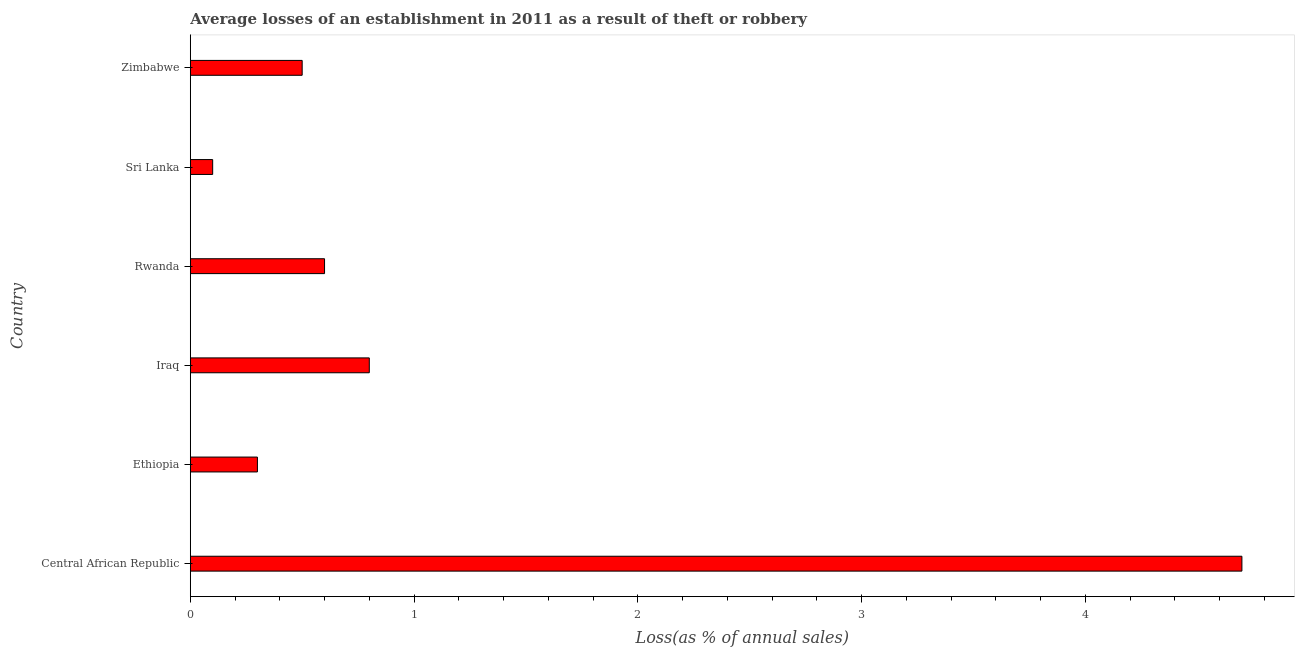Does the graph contain grids?
Offer a terse response. No. What is the title of the graph?
Your answer should be compact. Average losses of an establishment in 2011 as a result of theft or robbery. What is the label or title of the X-axis?
Your answer should be very brief. Loss(as % of annual sales). What is the label or title of the Y-axis?
Provide a succinct answer. Country. What is the losses due to theft in Ethiopia?
Offer a very short reply. 0.3. Across all countries, what is the minimum losses due to theft?
Provide a succinct answer. 0.1. In which country was the losses due to theft maximum?
Provide a succinct answer. Central African Republic. In which country was the losses due to theft minimum?
Ensure brevity in your answer.  Sri Lanka. What is the sum of the losses due to theft?
Your answer should be compact. 7. What is the average losses due to theft per country?
Your answer should be compact. 1.17. What is the median losses due to theft?
Your answer should be compact. 0.55. In how many countries, is the losses due to theft greater than 1.6 %?
Keep it short and to the point. 1. What is the ratio of the losses due to theft in Ethiopia to that in Iraq?
Keep it short and to the point. 0.38. Is the difference between the losses due to theft in Rwanda and Zimbabwe greater than the difference between any two countries?
Your answer should be compact. No. How many countries are there in the graph?
Offer a very short reply. 6. What is the difference between two consecutive major ticks on the X-axis?
Keep it short and to the point. 1. Are the values on the major ticks of X-axis written in scientific E-notation?
Keep it short and to the point. No. What is the Loss(as % of annual sales) in Central African Republic?
Ensure brevity in your answer.  4.7. What is the Loss(as % of annual sales) of Sri Lanka?
Your answer should be very brief. 0.1. What is the difference between the Loss(as % of annual sales) in Central African Republic and Ethiopia?
Provide a succinct answer. 4.4. What is the difference between the Loss(as % of annual sales) in Central African Republic and Iraq?
Offer a very short reply. 3.9. What is the difference between the Loss(as % of annual sales) in Central African Republic and Rwanda?
Offer a terse response. 4.1. What is the difference between the Loss(as % of annual sales) in Ethiopia and Iraq?
Offer a very short reply. -0.5. What is the difference between the Loss(as % of annual sales) in Iraq and Rwanda?
Offer a terse response. 0.2. What is the difference between the Loss(as % of annual sales) in Iraq and Sri Lanka?
Provide a short and direct response. 0.7. What is the difference between the Loss(as % of annual sales) in Sri Lanka and Zimbabwe?
Provide a short and direct response. -0.4. What is the ratio of the Loss(as % of annual sales) in Central African Republic to that in Ethiopia?
Your answer should be very brief. 15.67. What is the ratio of the Loss(as % of annual sales) in Central African Republic to that in Iraq?
Give a very brief answer. 5.88. What is the ratio of the Loss(as % of annual sales) in Central African Republic to that in Rwanda?
Give a very brief answer. 7.83. What is the ratio of the Loss(as % of annual sales) in Central African Republic to that in Sri Lanka?
Keep it short and to the point. 47. What is the ratio of the Loss(as % of annual sales) in Central African Republic to that in Zimbabwe?
Your answer should be very brief. 9.4. What is the ratio of the Loss(as % of annual sales) in Ethiopia to that in Rwanda?
Ensure brevity in your answer.  0.5. What is the ratio of the Loss(as % of annual sales) in Iraq to that in Rwanda?
Ensure brevity in your answer.  1.33. What is the ratio of the Loss(as % of annual sales) in Rwanda to that in Zimbabwe?
Your answer should be compact. 1.2. What is the ratio of the Loss(as % of annual sales) in Sri Lanka to that in Zimbabwe?
Ensure brevity in your answer.  0.2. 